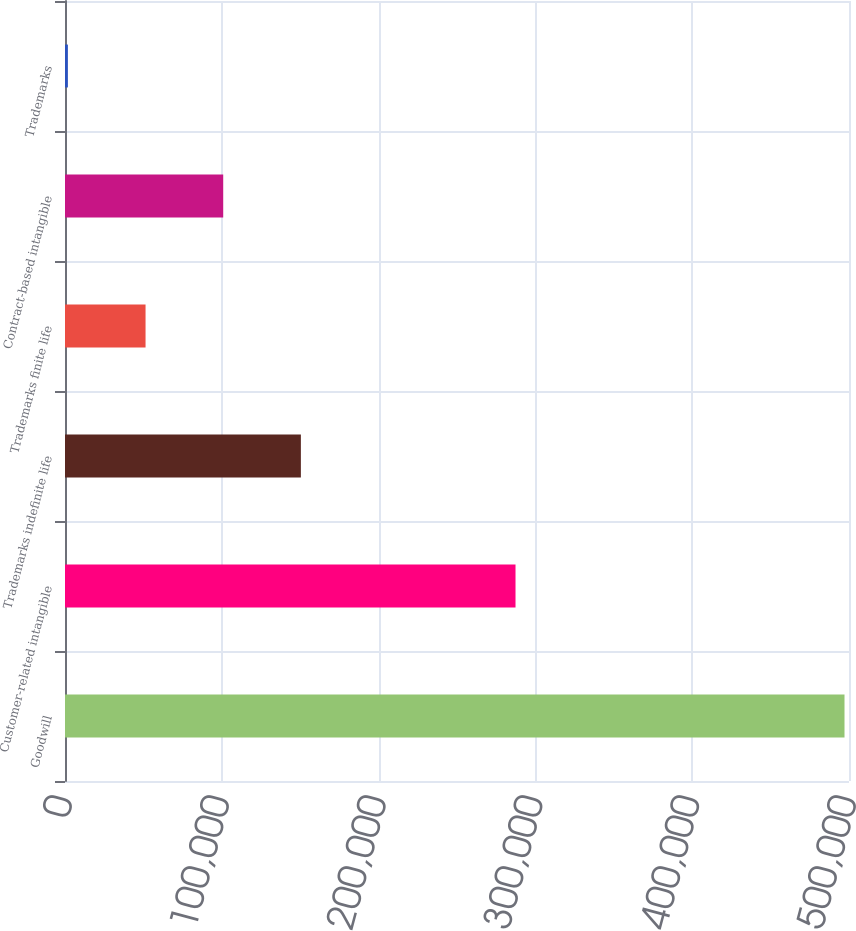Convert chart. <chart><loc_0><loc_0><loc_500><loc_500><bar_chart><fcel>Goodwill<fcel>Customer-related intangible<fcel>Trademarks indefinite life<fcel>Trademarks finite life<fcel>Contract-based intangible<fcel>Trademarks<nl><fcel>497136<fcel>287317<fcel>150430<fcel>51370.5<fcel>100900<fcel>1841<nl></chart> 